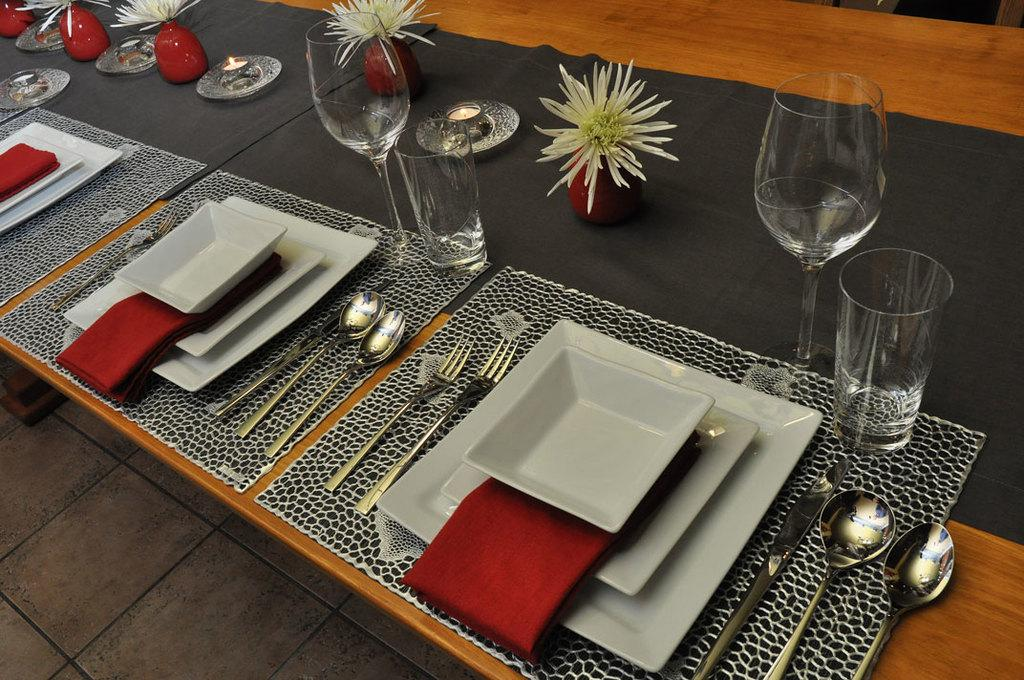What type of furniture is present in the image? There is a table in the image. What items are placed on the table? There are glasses, pots with flowers, a candle, plates, spoons, forks, a knife, napkins, and table mats on the table. Can you describe the table setting? The table setting includes glasses, plates, spoons, forks, a knife, and napkins. What might be used for decoration on the table? The pots with flowers can be used for decoration on the table. What type of religious symbol can be seen on the table? There is no religious symbol present on the table in the image. Can you describe the bird sitting on the table? There is no bird present on the table in the image. 